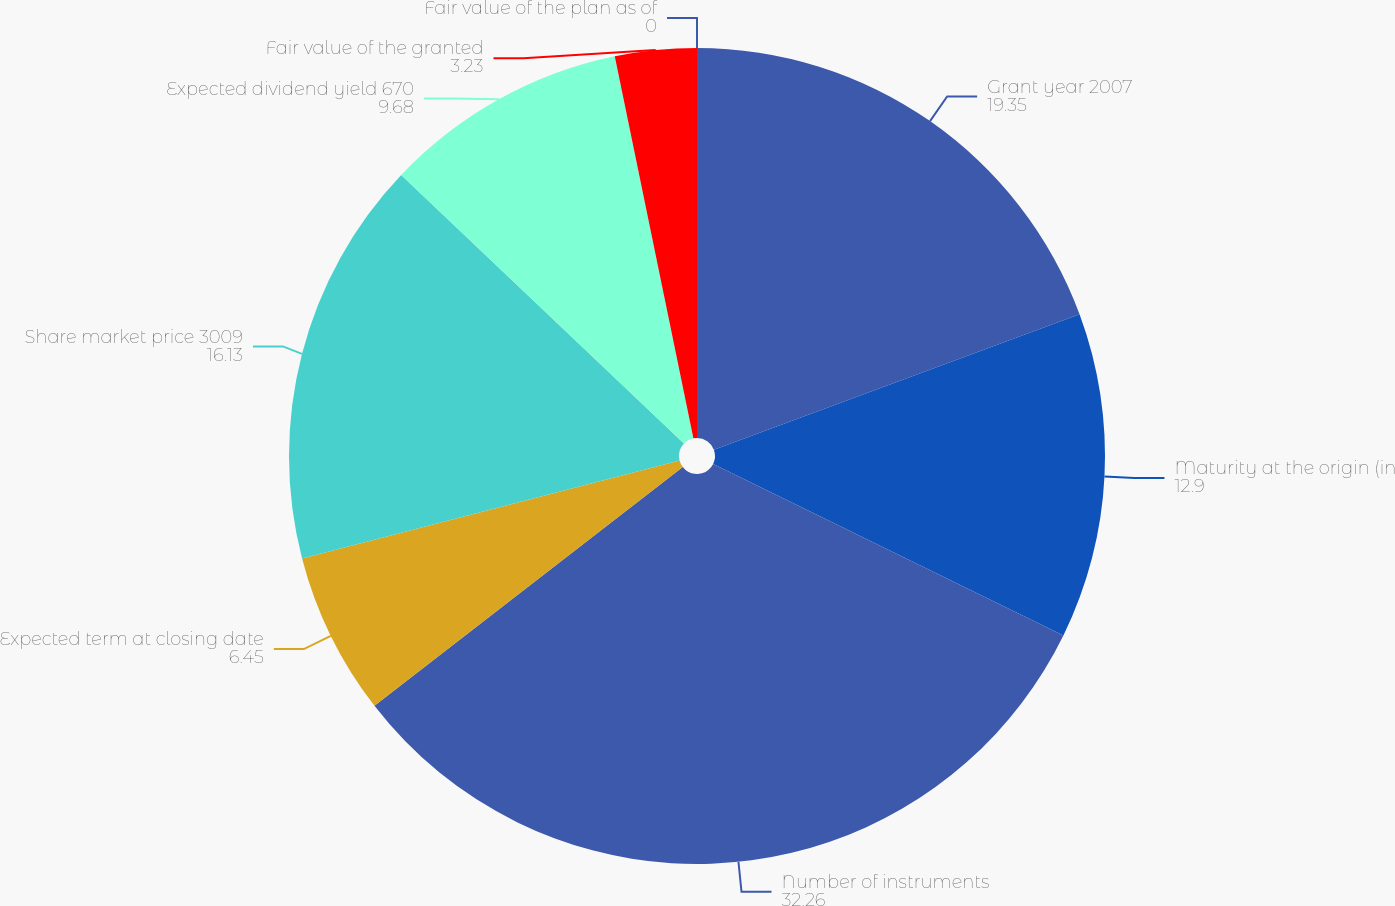<chart> <loc_0><loc_0><loc_500><loc_500><pie_chart><fcel>Grant year 2007<fcel>Maturity at the origin (in<fcel>Number of instruments<fcel>Expected term at closing date<fcel>Share market price 3009<fcel>Expected dividend yield 670<fcel>Fair value of the granted<fcel>Fair value of the plan as of<nl><fcel>19.35%<fcel>12.9%<fcel>32.26%<fcel>6.45%<fcel>16.13%<fcel>9.68%<fcel>3.23%<fcel>0.0%<nl></chart> 